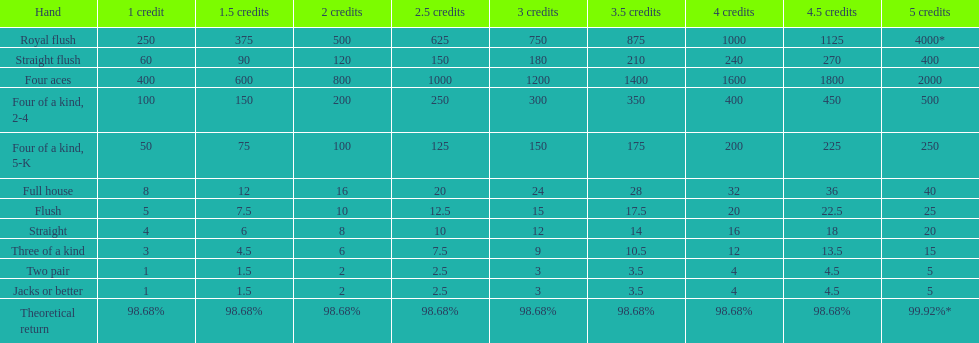What is the most superior four of a kind for a winning outcome? Four of a kind, 2-4. 